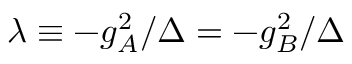<formula> <loc_0><loc_0><loc_500><loc_500>\lambda \equiv - g _ { A } ^ { 2 } / \Delta = - g _ { B } ^ { 2 } / \Delta</formula> 